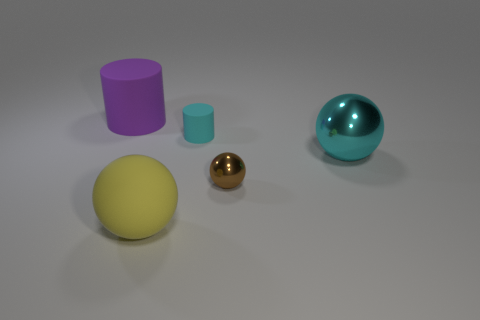Are there more purple matte cylinders to the left of the purple object than cyan matte cylinders behind the small cyan rubber cylinder? Upon reviewing the image, it appears that there is only one purple matte cylinder and it is to the left of its similar-colored spherical counterpart. As for the cyan objects, there are two distinct items: one matte cylinder that is larger and located behind the small cyan rubber cylinder. Therefore, the answer to the original question is no, since there is only one cyan matte cylinder and it is indeed behind the small cyan rubber cylinder, not outnumbering the single purple cylinder to the left of the purple sphere. 